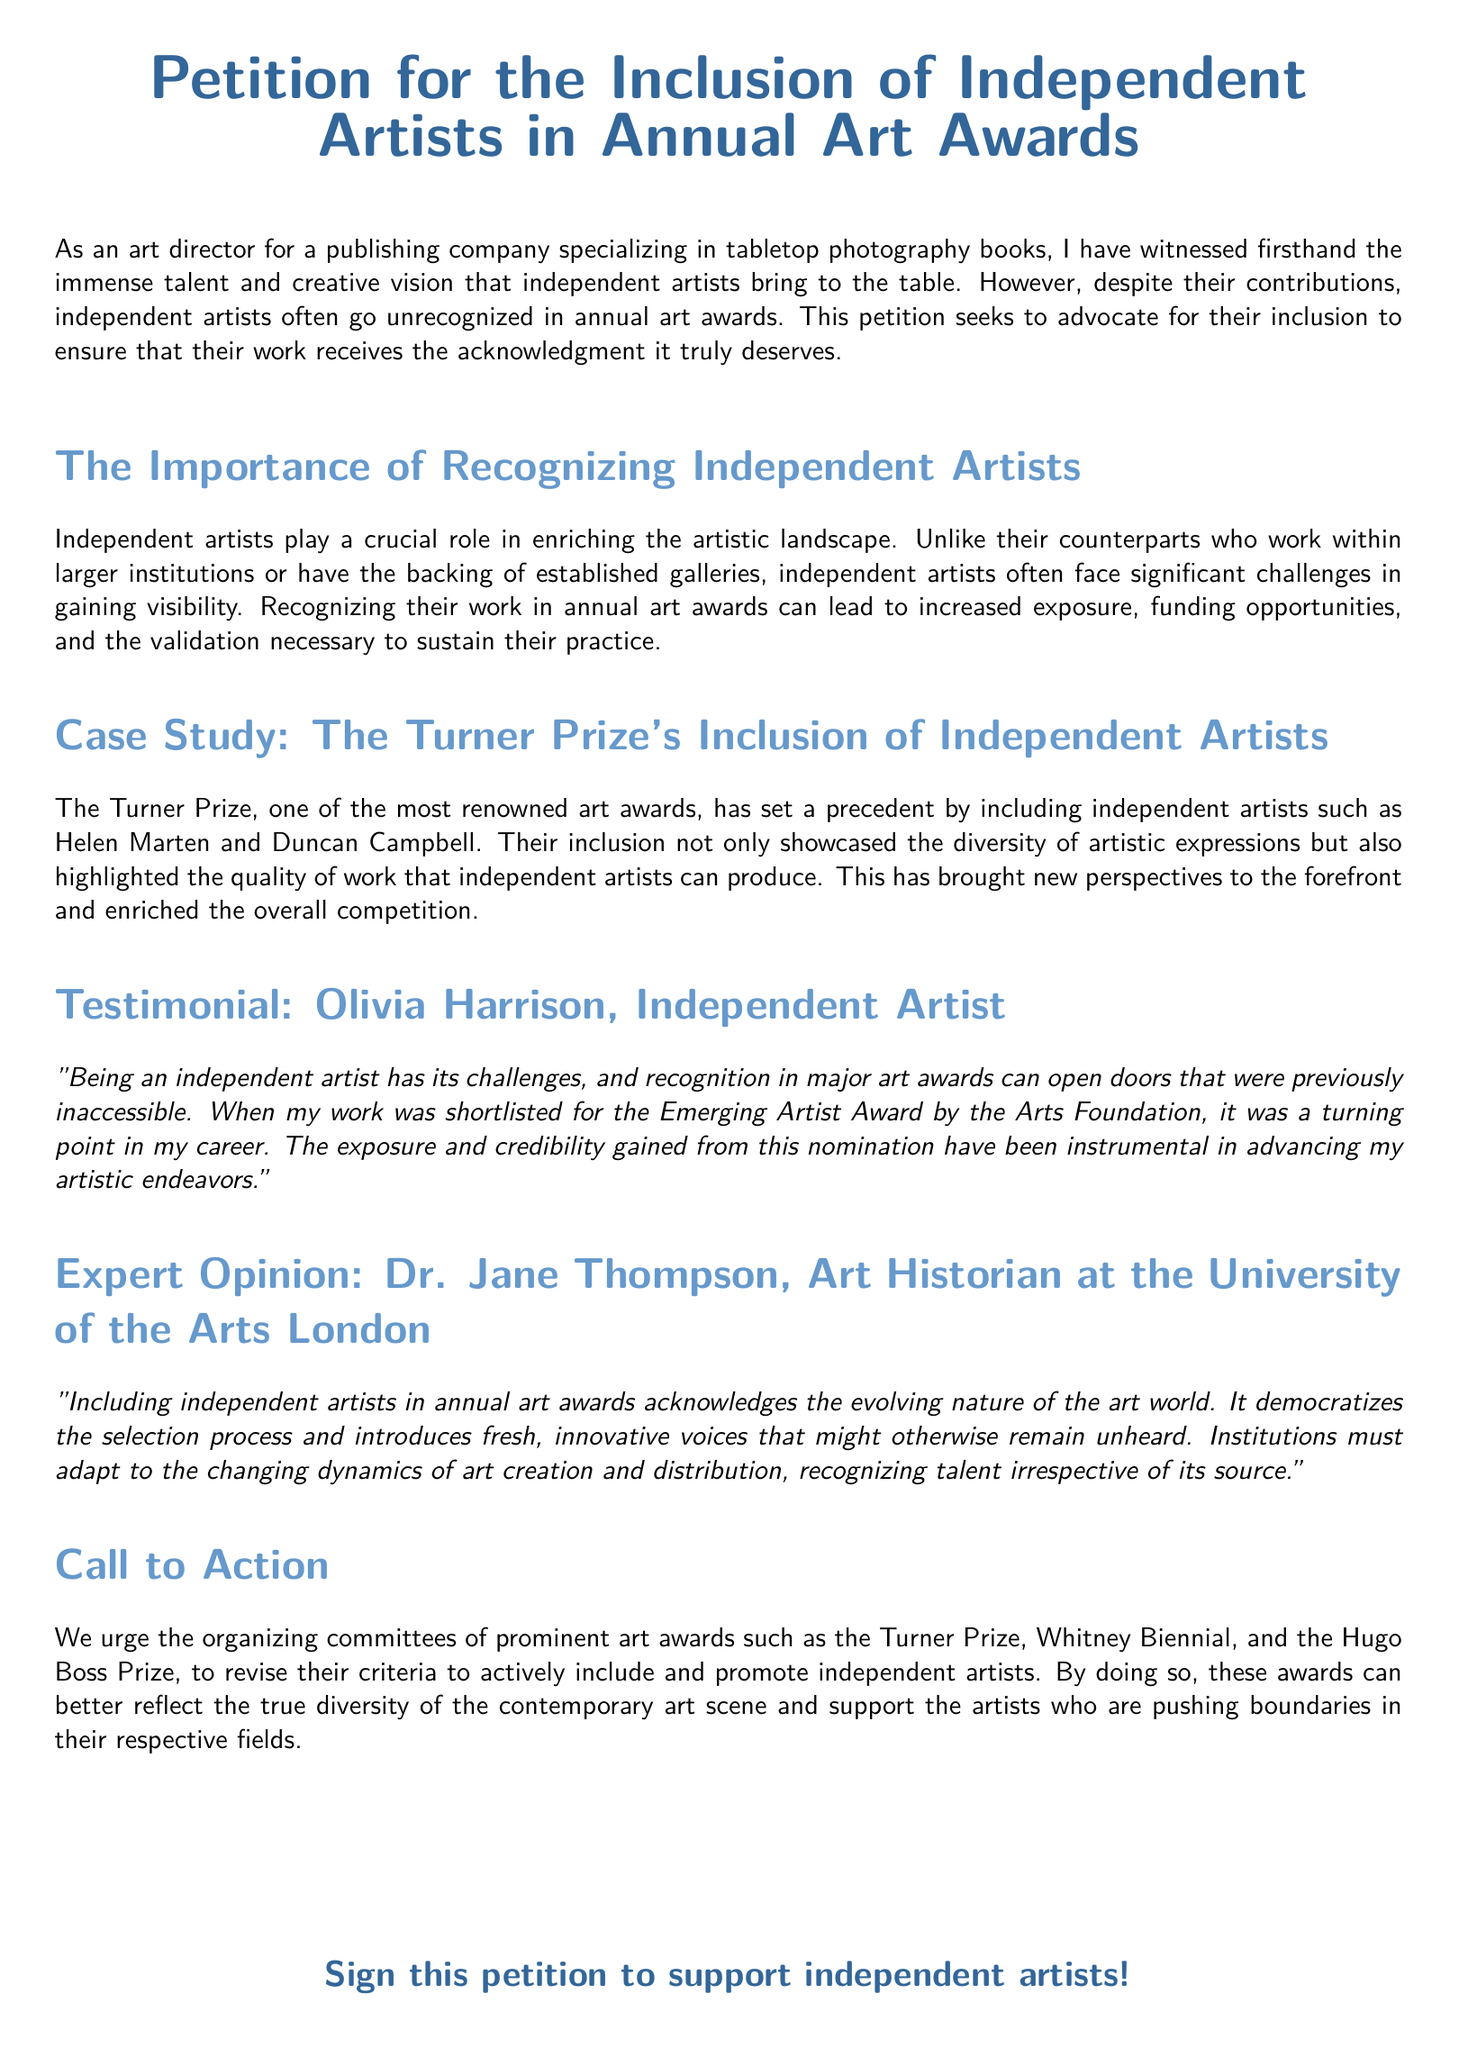What is the title of the petition? The title is clearly stated at the beginning of the document.
Answer: Petition for the Inclusion of Independent Artists in Annual Art Awards Who is the author of the testimonial? The document includes a testimonial from an independent artist.
Answer: Olivia Harrison What role do independent artists play according to the document? This section explains the contributions of independent artists to the art world.
Answer: Crucial role What notable art award is mentioned as having included independent artists? The document provides an example of this art award in a case study.
Answer: Turner Prize What did Olivia Harrison say was a turning point in her career? This part of the testimonial details a significant moment for the artist.
Answer: Shortlisted for the Emerging Artist Award Who is the expert quoted in the document? The document provides an expert opinion from a specific individual.
Answer: Dr. Jane Thompson What do the authors urge organizing committees to revise? The document describes a specific change that the authors are advocating for.
Answer: Criteria to actively include and promote independent artists What is one effect of including independent artists in awards, according to Dr. Jane Thompson? The expert opinion highlights a particular effect of such inclusion.
Answer: Democratizes the selection process 